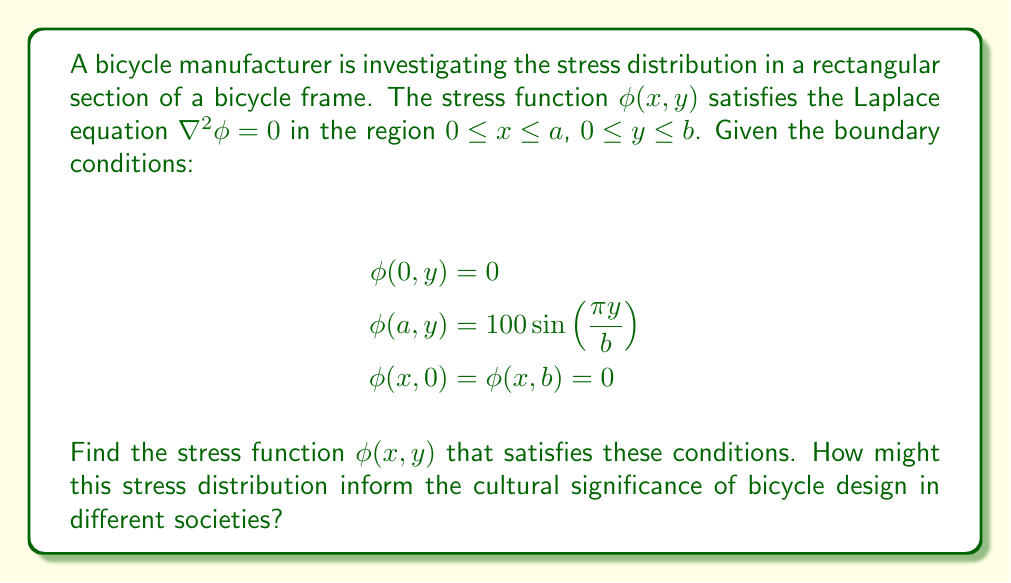Show me your answer to this math problem. To solve this problem, we'll use the method of separation of variables:

1) Assume the solution has the form $\phi(x,y) = X(x)Y(y)$.

2) Substituting into the Laplace equation:
   $$\frac{d^2X}{dx^2}Y + X\frac{d^2Y}{dy^2} = 0$$

3) Dividing by $XY$:
   $$\frac{1}{X}\frac{d^2X}{dx^2} = -\frac{1}{Y}\frac{d^2Y}{dy^2} = -\lambda^2$$

4) This gives us two ODEs:
   $$\frac{d^2X}{dx^2} + \lambda^2X = 0$$
   $$\frac{d^2Y}{dy^2} - \lambda^2Y = 0$$

5) The general solutions are:
   $$X(x) = A\cos(\lambda x) + B\sin(\lambda x)$$
   $$Y(y) = C\sinh(\lambda y) + D\cosh(\lambda y)$$

6) Applying the boundary conditions:
   $\phi(0,y) = 0$ implies $A = 0$
   $\phi(x,0) = \phi(x,b) = 0$ implies $Y(y) = \sin(\frac{n\pi y}{b})$, where $n$ is an integer

7) Therefore, $\lambda = \frac{n\pi}{b}$ and our solution has the form:
   $$\phi(x,y) = \sum_{n=1}^{\infty} B_n \sin(\frac{n\pi y}{b})\sinh(\frac{n\pi x}{b})$$

8) The final boundary condition $\phi(a,y) = 100\sin(\frac{\pi y}{b})$ implies that only $n=1$ contributes, and:
   $$100 = B_1\sinh(\frac{\pi a}{b})$$

9) Solving for $B_1$:
   $$B_1 = \frac{100}{\sinh(\frac{\pi a}{b})}$$

Therefore, the final solution is:
$$\phi(x,y) = \frac{100\sinh(\frac{\pi x}{b})}{\sinh(\frac{\pi a}{b})}\sin(\frac{\pi y}{b})$$

This solution represents the stress distribution in the bicycle frame section. The stress is highest at the edges and decreases towards the center. In different cultures, the perception of bicycle design and safety could be influenced by such stress distributions. For example, cultures prioritizing safety might prefer designs that minimize stress concentrations, while others might value lightweight designs that push material limits.
Answer: $$\phi(x,y) = \frac{100\sinh(\frac{\pi x}{b})}{\sinh(\frac{\pi a}{b})}\sin(\frac{\pi y}{b})$$ 